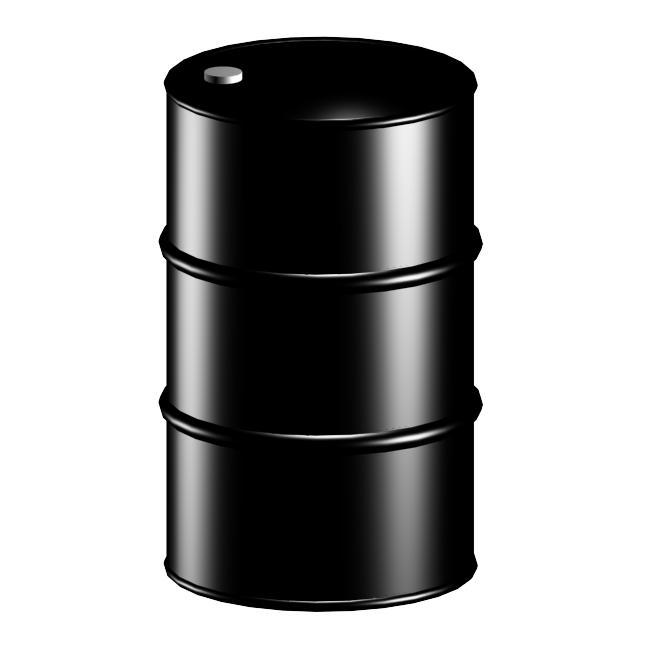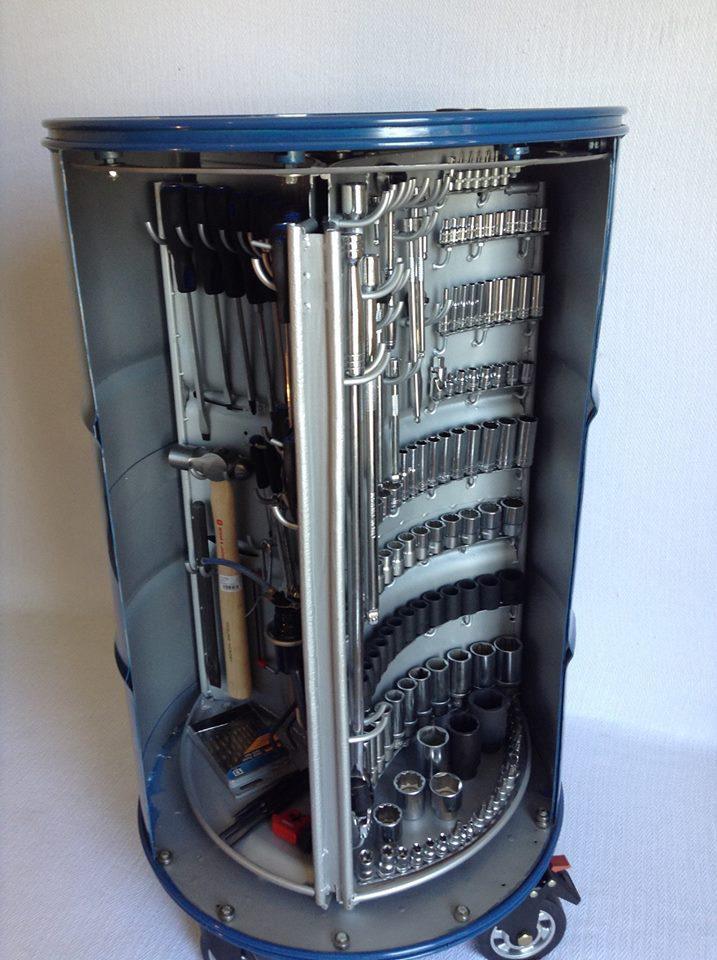The first image is the image on the left, the second image is the image on the right. Considering the images on both sides, is "there is an empty drum open so the inside is viewable" valid? Answer yes or no. No. The first image is the image on the left, the second image is the image on the right. For the images shown, is this caption "The right image shows an empty barrel with a hinged opening, and the left image shows a tool-filled blue barrel with an open front." true? Answer yes or no. No. 